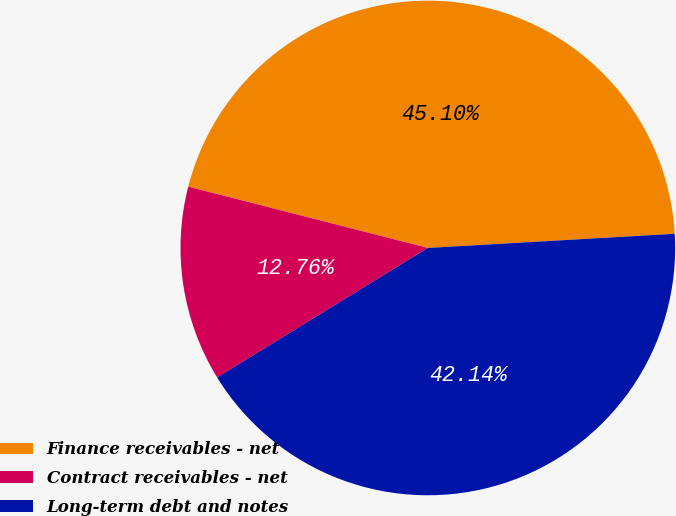Convert chart to OTSL. <chart><loc_0><loc_0><loc_500><loc_500><pie_chart><fcel>Finance receivables - net<fcel>Contract receivables - net<fcel>Long-term debt and notes<nl><fcel>45.1%<fcel>12.76%<fcel>42.14%<nl></chart> 